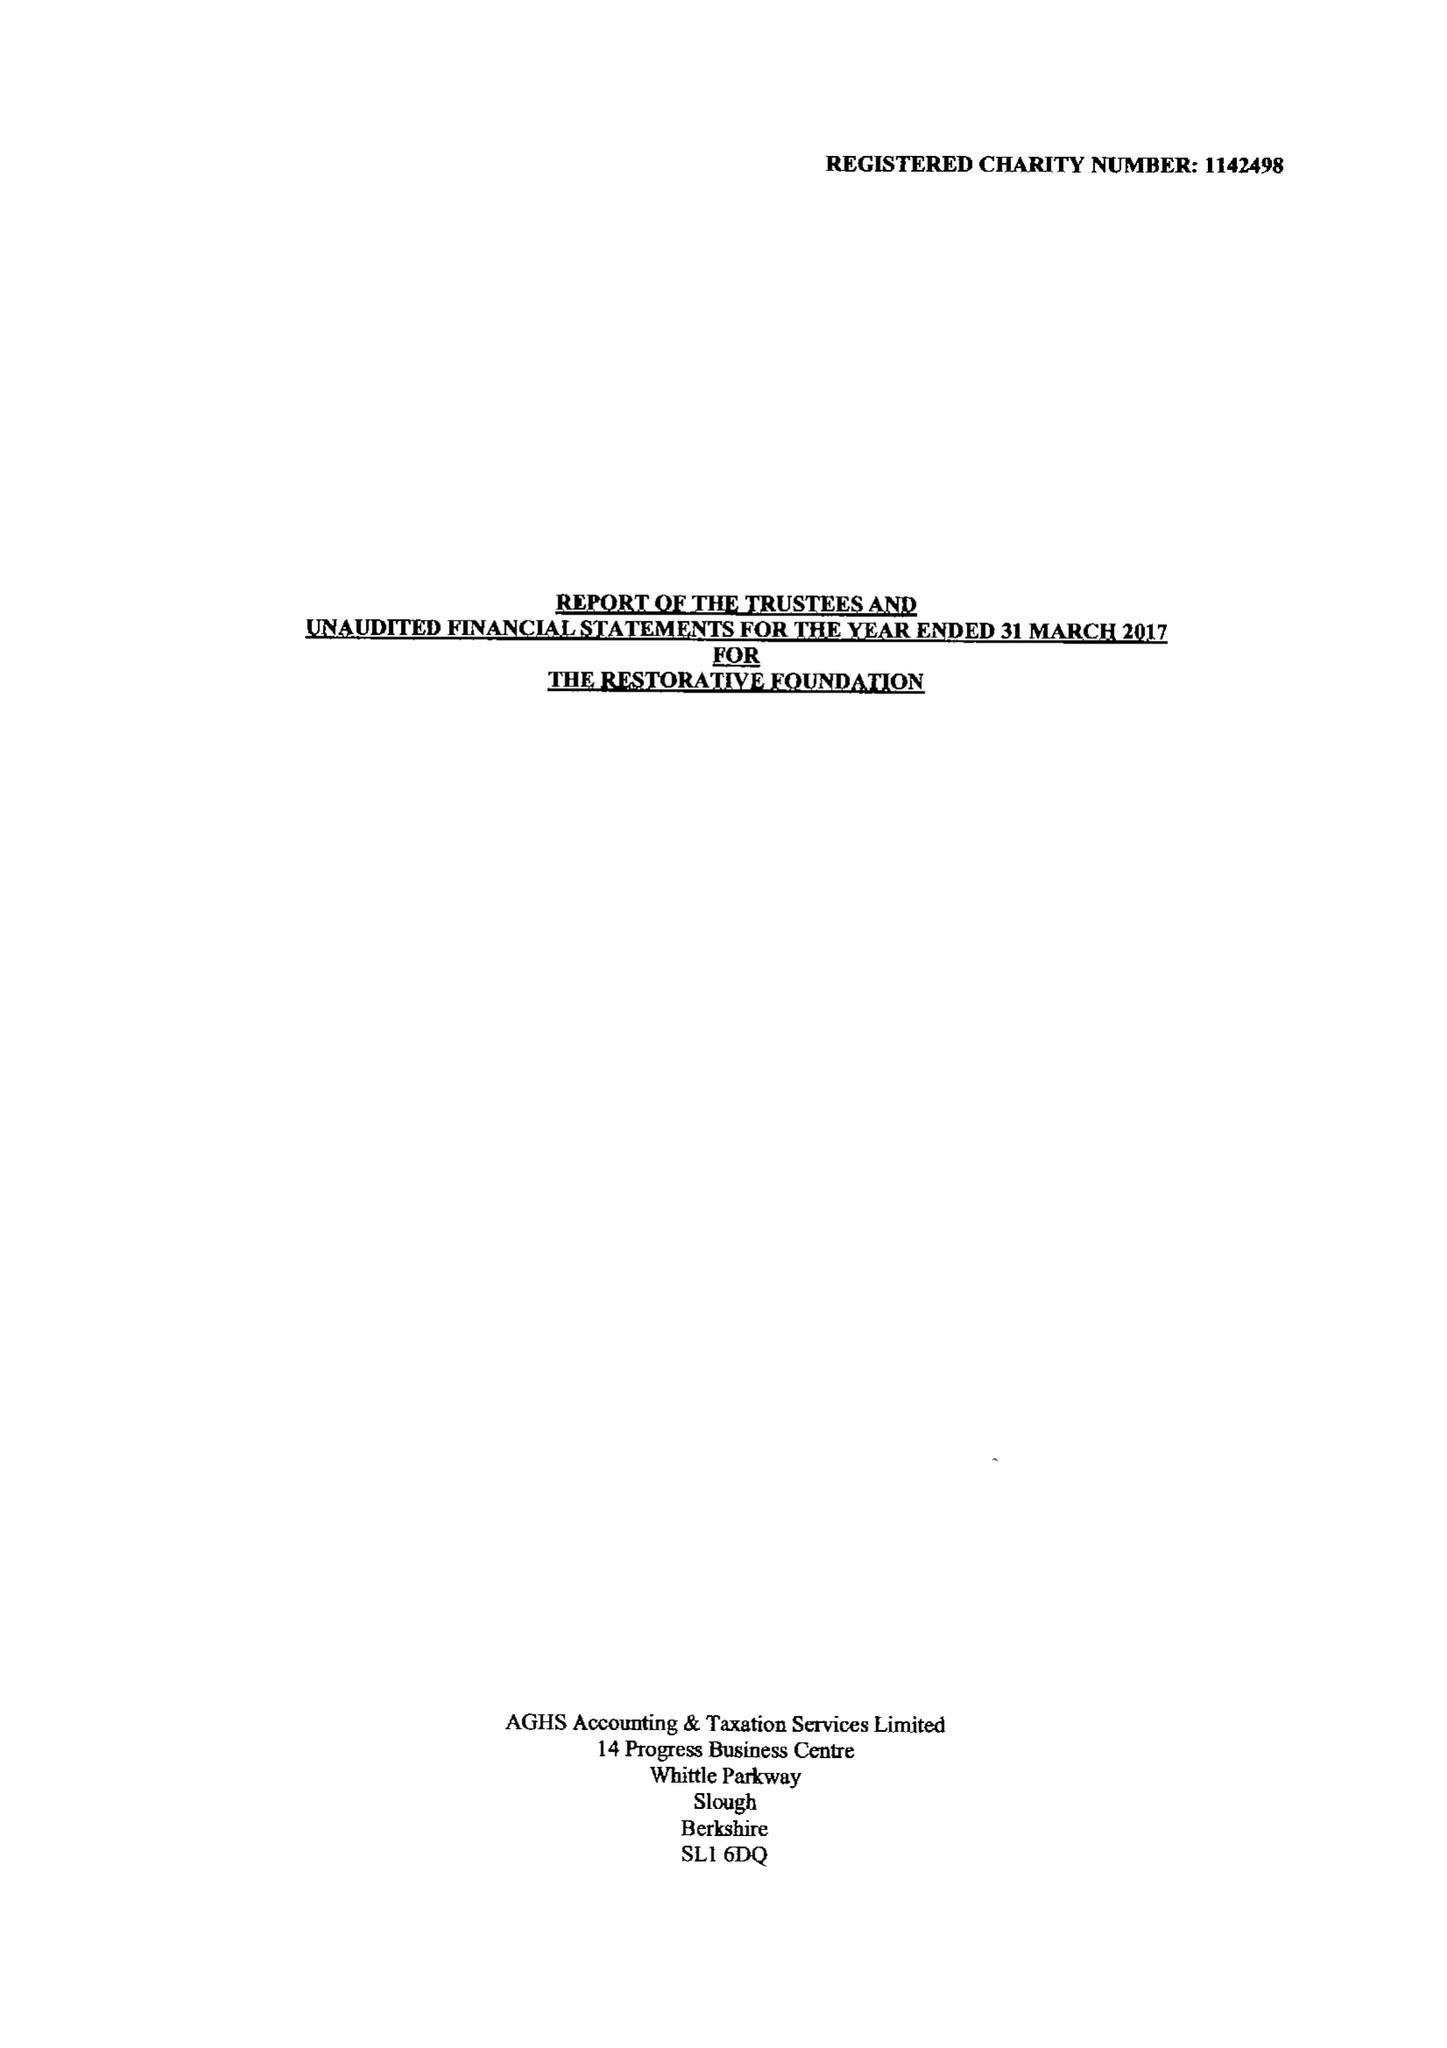What is the value for the address__postcode?
Answer the question using a single word or phrase. UB8 1QG 